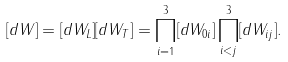Convert formula to latex. <formula><loc_0><loc_0><loc_500><loc_500>[ d W ] = [ d W _ { L } ] [ d W _ { T } ] = \prod _ { i = 1 } ^ { 3 } [ d W _ { 0 i } ] \prod _ { i < j } ^ { 3 } [ d W _ { i j } ] .</formula> 